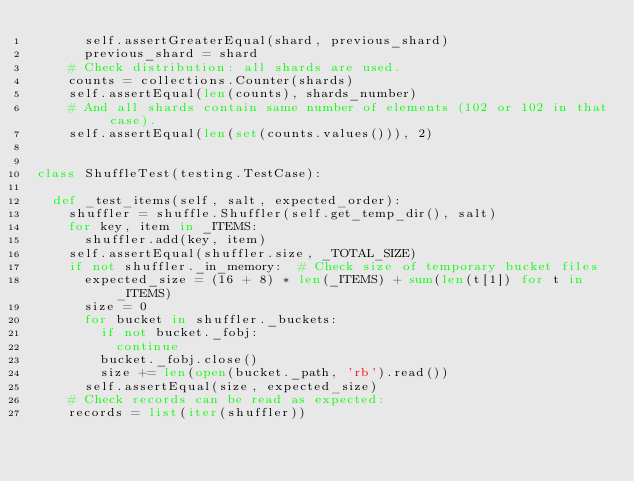Convert code to text. <code><loc_0><loc_0><loc_500><loc_500><_Python_>      self.assertGreaterEqual(shard, previous_shard)
      previous_shard = shard
    # Check distribution: all shards are used.
    counts = collections.Counter(shards)
    self.assertEqual(len(counts), shards_number)
    # And all shards contain same number of elements (102 or 102 in that case).
    self.assertEqual(len(set(counts.values())), 2)


class ShuffleTest(testing.TestCase):

  def _test_items(self, salt, expected_order):
    shuffler = shuffle.Shuffler(self.get_temp_dir(), salt)
    for key, item in _ITEMS:
      shuffler.add(key, item)
    self.assertEqual(shuffler.size, _TOTAL_SIZE)
    if not shuffler._in_memory:  # Check size of temporary bucket files
      expected_size = (16 + 8) * len(_ITEMS) + sum(len(t[1]) for t in _ITEMS)
      size = 0
      for bucket in shuffler._buckets:
        if not bucket._fobj:
          continue
        bucket._fobj.close()
        size += len(open(bucket._path, 'rb').read())
      self.assertEqual(size, expected_size)
    # Check records can be read as expected:
    records = list(iter(shuffler))</code> 